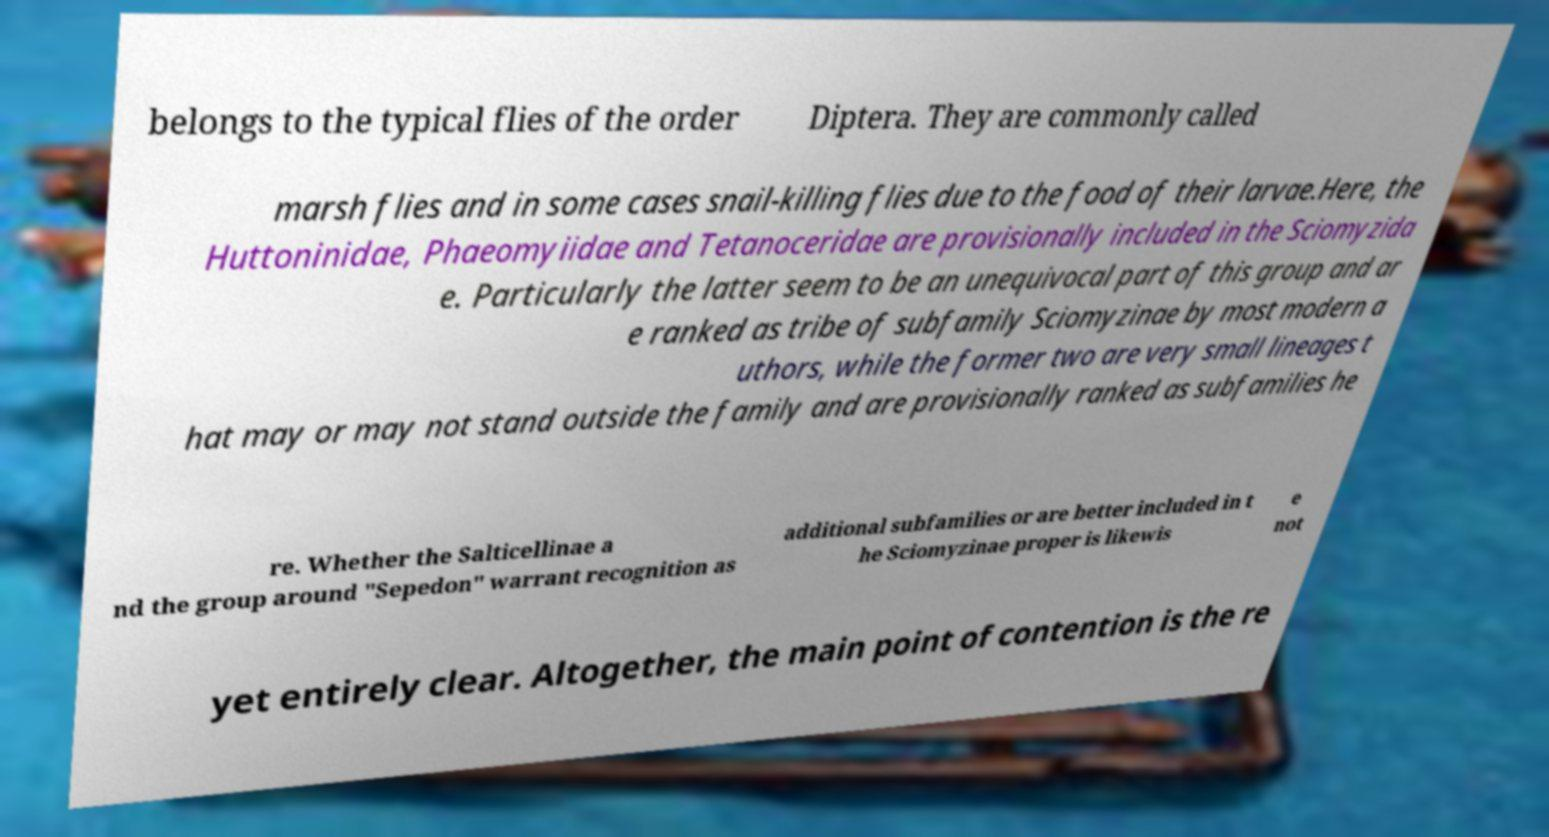For documentation purposes, I need the text within this image transcribed. Could you provide that? belongs to the typical flies of the order Diptera. They are commonly called marsh flies and in some cases snail-killing flies due to the food of their larvae.Here, the Huttoninidae, Phaeomyiidae and Tetanoceridae are provisionally included in the Sciomyzida e. Particularly the latter seem to be an unequivocal part of this group and ar e ranked as tribe of subfamily Sciomyzinae by most modern a uthors, while the former two are very small lineages t hat may or may not stand outside the family and are provisionally ranked as subfamilies he re. Whether the Salticellinae a nd the group around "Sepedon" warrant recognition as additional subfamilies or are better included in t he Sciomyzinae proper is likewis e not yet entirely clear. Altogether, the main point of contention is the re 